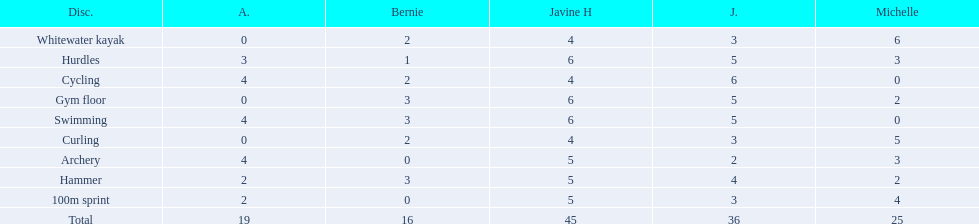What is the last discipline listed on this chart? 100m sprint. 